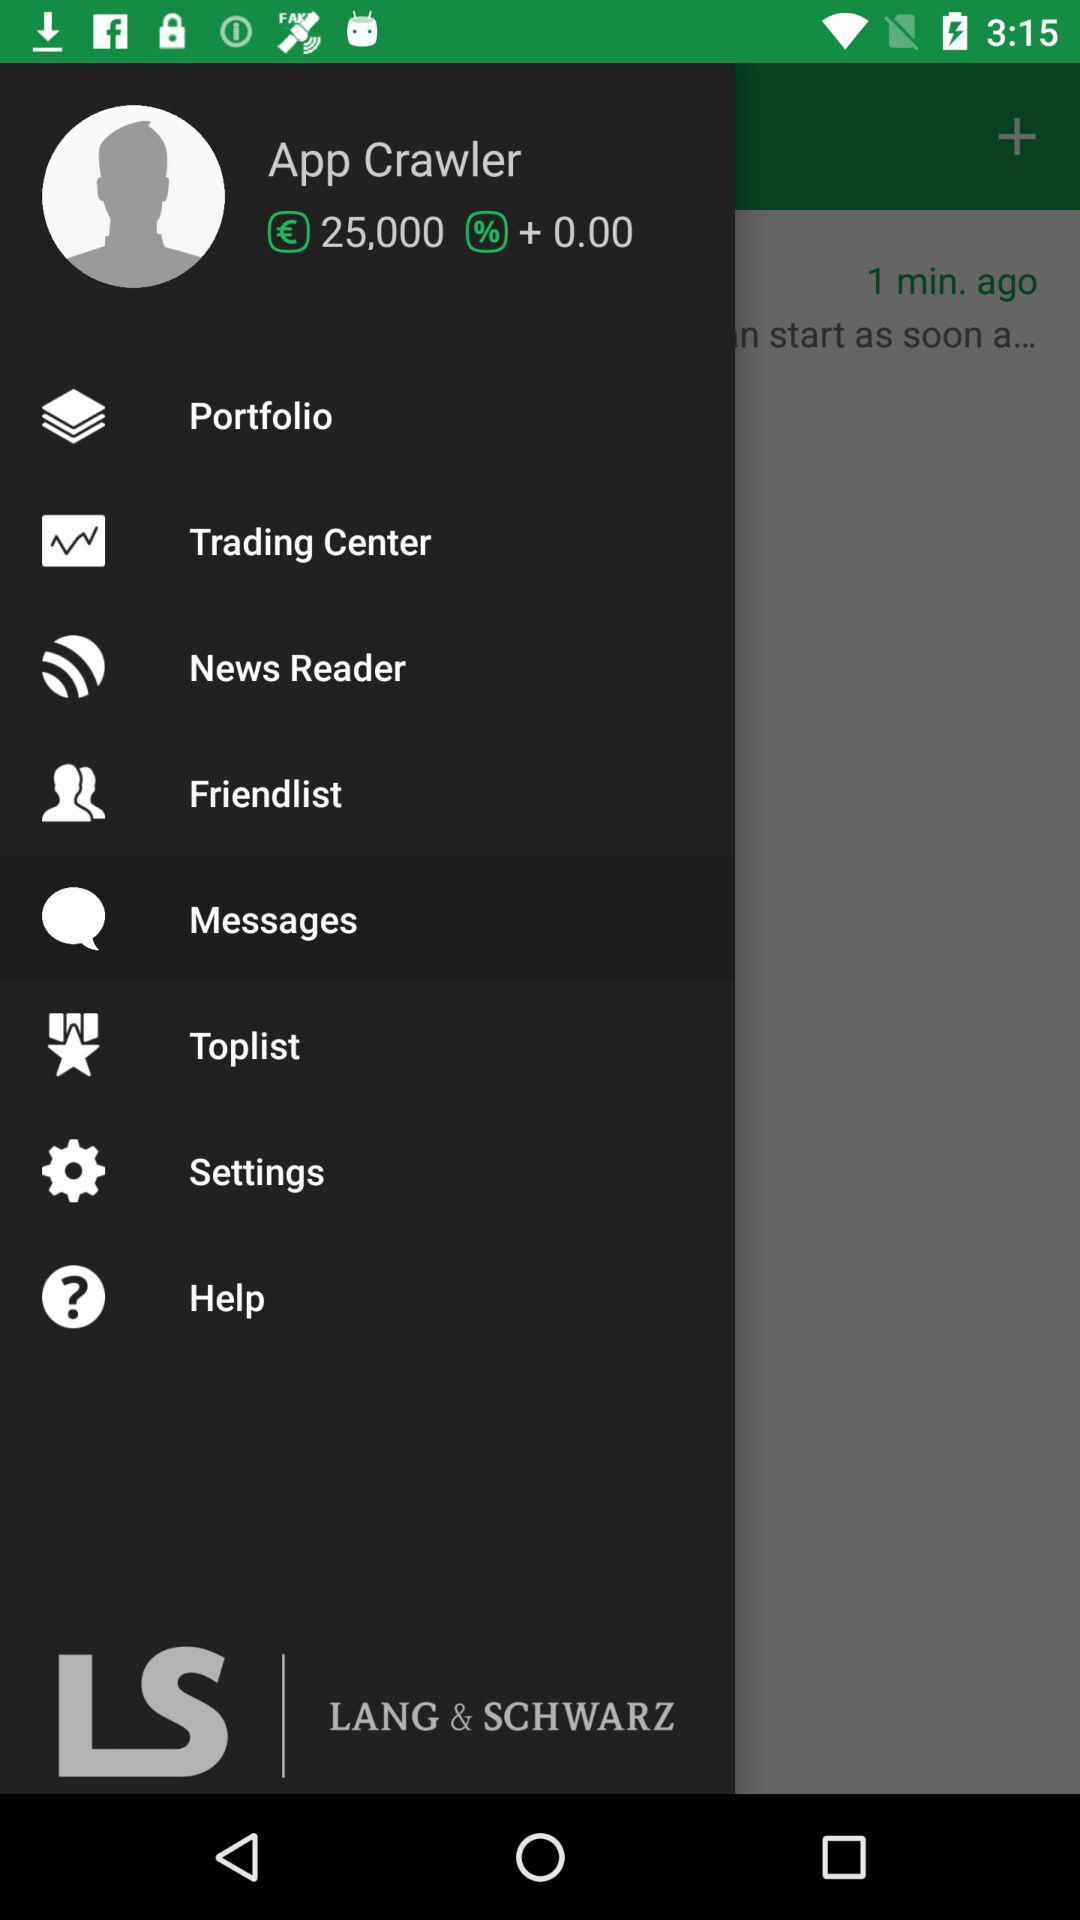What is the balance? The balance is €25,000. 